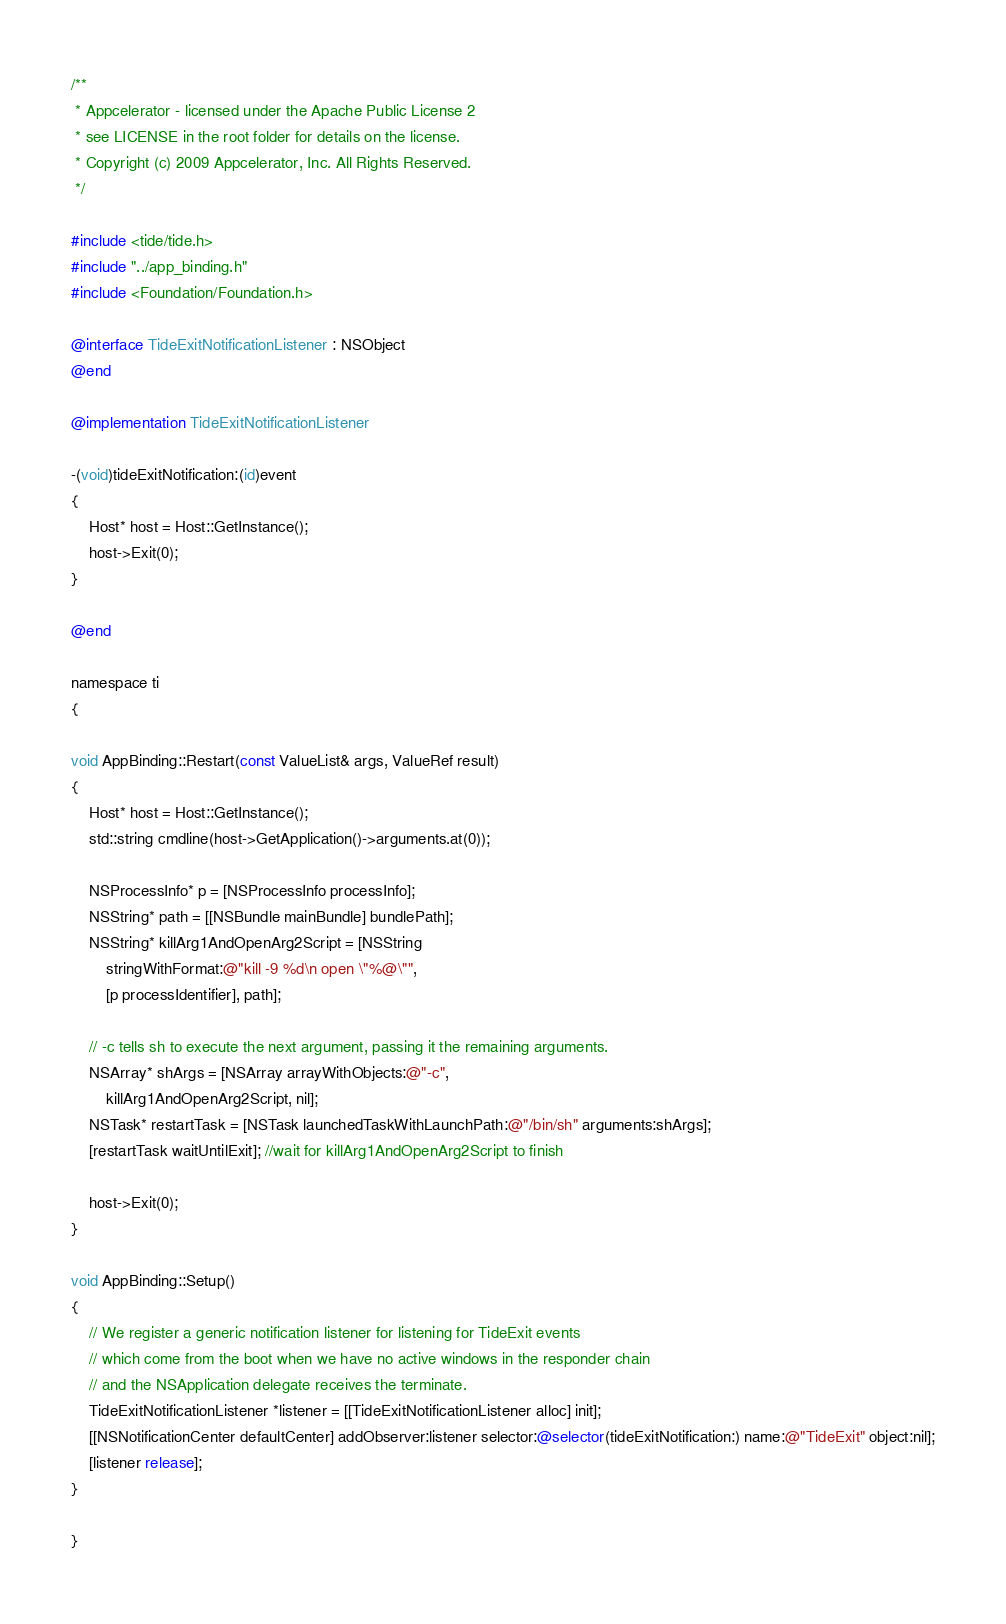Convert code to text. <code><loc_0><loc_0><loc_500><loc_500><_ObjectiveC_>/**
 * Appcelerator - licensed under the Apache Public License 2
 * see LICENSE in the root folder for details on the license.
 * Copyright (c) 2009 Appcelerator, Inc. All Rights Reserved.
 */

#include <tide/tide.h>
#include "../app_binding.h"
#include <Foundation/Foundation.h>

@interface TideExitNotificationListener : NSObject
@end

@implementation TideExitNotificationListener

-(void)tideExitNotification:(id)event
{
	Host* host = Host::GetInstance();
	host->Exit(0);
}

@end

namespace ti
{

void AppBinding::Restart(const ValueList& args, ValueRef result)
{
	Host* host = Host::GetInstance();
	std::string cmdline(host->GetApplication()->arguments.at(0));

	NSProcessInfo* p = [NSProcessInfo processInfo];
	NSString* path = [[NSBundle mainBundle] bundlePath];
	NSString* killArg1AndOpenArg2Script = [NSString 
		stringWithFormat:@"kill -9 %d\n open \"%@\"",
		[p processIdentifier], path];

	// -c tells sh to execute the next argument, passing it the remaining arguments.
	NSArray* shArgs = [NSArray arrayWithObjects:@"-c",
		killArg1AndOpenArg2Script, nil];
	NSTask* restartTask = [NSTask launchedTaskWithLaunchPath:@"/bin/sh" arguments:shArgs];
	[restartTask waitUntilExit]; //wait for killArg1AndOpenArg2Script to finish

	host->Exit(0);
}

void AppBinding::Setup() 
{
	// We register a generic notification listener for listening for TideExit events
	// which come from the boot when we have no active windows in the responder chain
	// and the NSApplication delegate receives the terminate.  
	TideExitNotificationListener *listener = [[TideExitNotificationListener alloc] init];
	[[NSNotificationCenter defaultCenter] addObserver:listener selector:@selector(tideExitNotification:) name:@"TideExit" object:nil];
	[listener release];
}

}
</code> 